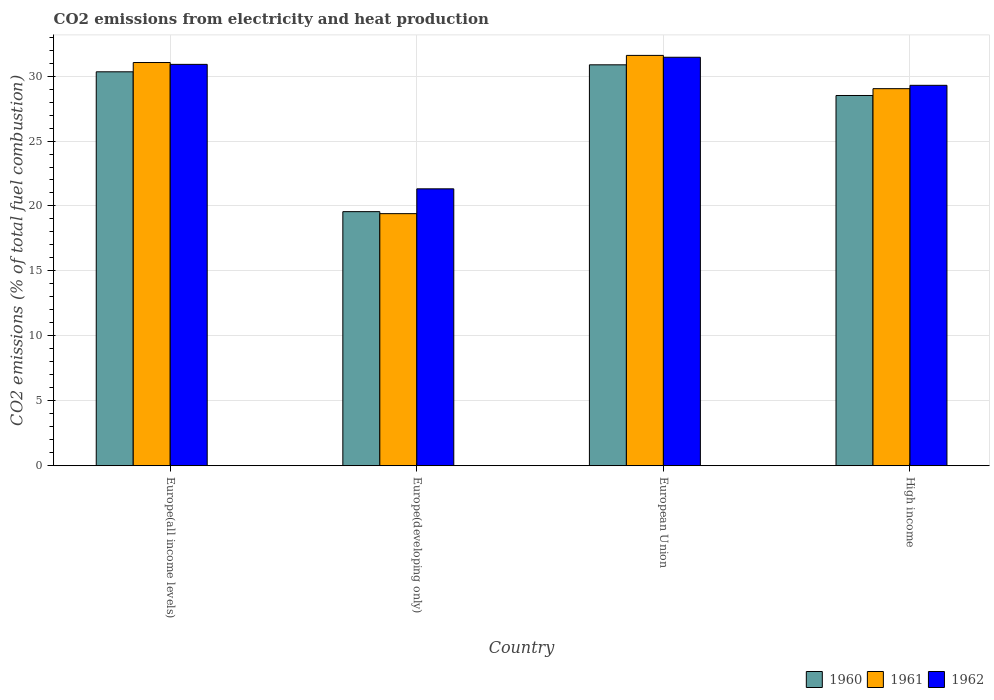How many groups of bars are there?
Your response must be concise. 4. Are the number of bars on each tick of the X-axis equal?
Your answer should be compact. Yes. How many bars are there on the 3rd tick from the right?
Your answer should be compact. 3. What is the label of the 4th group of bars from the left?
Your answer should be compact. High income. In how many cases, is the number of bars for a given country not equal to the number of legend labels?
Offer a terse response. 0. What is the amount of CO2 emitted in 1960 in High income?
Ensure brevity in your answer.  28.51. Across all countries, what is the maximum amount of CO2 emitted in 1960?
Your answer should be very brief. 30.87. Across all countries, what is the minimum amount of CO2 emitted in 1961?
Offer a very short reply. 19.41. In which country was the amount of CO2 emitted in 1962 minimum?
Provide a short and direct response. Europe(developing only). What is the total amount of CO2 emitted in 1960 in the graph?
Keep it short and to the point. 109.27. What is the difference between the amount of CO2 emitted in 1960 in Europe(developing only) and that in High income?
Offer a terse response. -8.94. What is the difference between the amount of CO2 emitted in 1960 in High income and the amount of CO2 emitted in 1961 in European Union?
Provide a succinct answer. -3.09. What is the average amount of CO2 emitted in 1962 per country?
Make the answer very short. 28.24. What is the difference between the amount of CO2 emitted of/in 1961 and amount of CO2 emitted of/in 1962 in European Union?
Keep it short and to the point. 0.14. In how many countries, is the amount of CO2 emitted in 1961 greater than 27 %?
Offer a very short reply. 3. What is the ratio of the amount of CO2 emitted in 1960 in Europe(all income levels) to that in Europe(developing only)?
Ensure brevity in your answer.  1.55. What is the difference between the highest and the second highest amount of CO2 emitted in 1962?
Your answer should be very brief. -1.61. What is the difference between the highest and the lowest amount of CO2 emitted in 1960?
Ensure brevity in your answer.  11.31. What does the 2nd bar from the left in Europe(all income levels) represents?
Give a very brief answer. 1961. What does the 3rd bar from the right in High income represents?
Give a very brief answer. 1960. How many countries are there in the graph?
Provide a short and direct response. 4. Are the values on the major ticks of Y-axis written in scientific E-notation?
Offer a terse response. No. Does the graph contain any zero values?
Your answer should be very brief. No. Where does the legend appear in the graph?
Provide a succinct answer. Bottom right. What is the title of the graph?
Provide a succinct answer. CO2 emissions from electricity and heat production. What is the label or title of the X-axis?
Keep it short and to the point. Country. What is the label or title of the Y-axis?
Your response must be concise. CO2 emissions (% of total fuel combustion). What is the CO2 emissions (% of total fuel combustion) of 1960 in Europe(all income levels)?
Give a very brief answer. 30.33. What is the CO2 emissions (% of total fuel combustion) of 1961 in Europe(all income levels)?
Provide a succinct answer. 31.04. What is the CO2 emissions (% of total fuel combustion) in 1962 in Europe(all income levels)?
Make the answer very short. 30.9. What is the CO2 emissions (% of total fuel combustion) in 1960 in Europe(developing only)?
Make the answer very short. 19.56. What is the CO2 emissions (% of total fuel combustion) of 1961 in Europe(developing only)?
Offer a terse response. 19.41. What is the CO2 emissions (% of total fuel combustion) in 1962 in Europe(developing only)?
Offer a very short reply. 21.32. What is the CO2 emissions (% of total fuel combustion) in 1960 in European Union?
Provide a short and direct response. 30.87. What is the CO2 emissions (% of total fuel combustion) in 1961 in European Union?
Keep it short and to the point. 31.59. What is the CO2 emissions (% of total fuel combustion) in 1962 in European Union?
Keep it short and to the point. 31.45. What is the CO2 emissions (% of total fuel combustion) in 1960 in High income?
Offer a very short reply. 28.51. What is the CO2 emissions (% of total fuel combustion) of 1961 in High income?
Your response must be concise. 29.03. What is the CO2 emissions (% of total fuel combustion) in 1962 in High income?
Offer a very short reply. 29.29. Across all countries, what is the maximum CO2 emissions (% of total fuel combustion) in 1960?
Offer a terse response. 30.87. Across all countries, what is the maximum CO2 emissions (% of total fuel combustion) in 1961?
Ensure brevity in your answer.  31.59. Across all countries, what is the maximum CO2 emissions (% of total fuel combustion) of 1962?
Keep it short and to the point. 31.45. Across all countries, what is the minimum CO2 emissions (% of total fuel combustion) in 1960?
Offer a terse response. 19.56. Across all countries, what is the minimum CO2 emissions (% of total fuel combustion) of 1961?
Your response must be concise. 19.41. Across all countries, what is the minimum CO2 emissions (% of total fuel combustion) in 1962?
Ensure brevity in your answer.  21.32. What is the total CO2 emissions (% of total fuel combustion) of 1960 in the graph?
Offer a very short reply. 109.27. What is the total CO2 emissions (% of total fuel combustion) of 1961 in the graph?
Offer a very short reply. 111.08. What is the total CO2 emissions (% of total fuel combustion) in 1962 in the graph?
Your answer should be very brief. 112.96. What is the difference between the CO2 emissions (% of total fuel combustion) in 1960 in Europe(all income levels) and that in Europe(developing only)?
Offer a terse response. 10.77. What is the difference between the CO2 emissions (% of total fuel combustion) of 1961 in Europe(all income levels) and that in Europe(developing only)?
Give a very brief answer. 11.64. What is the difference between the CO2 emissions (% of total fuel combustion) of 1962 in Europe(all income levels) and that in Europe(developing only)?
Offer a very short reply. 9.58. What is the difference between the CO2 emissions (% of total fuel combustion) of 1960 in Europe(all income levels) and that in European Union?
Keep it short and to the point. -0.54. What is the difference between the CO2 emissions (% of total fuel combustion) in 1961 in Europe(all income levels) and that in European Union?
Offer a terse response. -0.55. What is the difference between the CO2 emissions (% of total fuel combustion) of 1962 in Europe(all income levels) and that in European Union?
Your response must be concise. -0.55. What is the difference between the CO2 emissions (% of total fuel combustion) of 1960 in Europe(all income levels) and that in High income?
Offer a terse response. 1.82. What is the difference between the CO2 emissions (% of total fuel combustion) in 1961 in Europe(all income levels) and that in High income?
Ensure brevity in your answer.  2.01. What is the difference between the CO2 emissions (% of total fuel combustion) of 1962 in Europe(all income levels) and that in High income?
Ensure brevity in your answer.  1.61. What is the difference between the CO2 emissions (% of total fuel combustion) in 1960 in Europe(developing only) and that in European Union?
Ensure brevity in your answer.  -11.31. What is the difference between the CO2 emissions (% of total fuel combustion) in 1961 in Europe(developing only) and that in European Union?
Your response must be concise. -12.19. What is the difference between the CO2 emissions (% of total fuel combustion) in 1962 in Europe(developing only) and that in European Union?
Provide a short and direct response. -10.13. What is the difference between the CO2 emissions (% of total fuel combustion) of 1960 in Europe(developing only) and that in High income?
Provide a short and direct response. -8.94. What is the difference between the CO2 emissions (% of total fuel combustion) of 1961 in Europe(developing only) and that in High income?
Make the answer very short. -9.62. What is the difference between the CO2 emissions (% of total fuel combustion) in 1962 in Europe(developing only) and that in High income?
Your answer should be very brief. -7.97. What is the difference between the CO2 emissions (% of total fuel combustion) in 1960 in European Union and that in High income?
Provide a succinct answer. 2.36. What is the difference between the CO2 emissions (% of total fuel combustion) in 1961 in European Union and that in High income?
Your answer should be very brief. 2.56. What is the difference between the CO2 emissions (% of total fuel combustion) of 1962 in European Union and that in High income?
Give a very brief answer. 2.16. What is the difference between the CO2 emissions (% of total fuel combustion) of 1960 in Europe(all income levels) and the CO2 emissions (% of total fuel combustion) of 1961 in Europe(developing only)?
Make the answer very short. 10.92. What is the difference between the CO2 emissions (% of total fuel combustion) of 1960 in Europe(all income levels) and the CO2 emissions (% of total fuel combustion) of 1962 in Europe(developing only)?
Offer a terse response. 9.01. What is the difference between the CO2 emissions (% of total fuel combustion) in 1961 in Europe(all income levels) and the CO2 emissions (% of total fuel combustion) in 1962 in Europe(developing only)?
Your answer should be compact. 9.73. What is the difference between the CO2 emissions (% of total fuel combustion) of 1960 in Europe(all income levels) and the CO2 emissions (% of total fuel combustion) of 1961 in European Union?
Provide a short and direct response. -1.26. What is the difference between the CO2 emissions (% of total fuel combustion) of 1960 in Europe(all income levels) and the CO2 emissions (% of total fuel combustion) of 1962 in European Union?
Your response must be concise. -1.12. What is the difference between the CO2 emissions (% of total fuel combustion) of 1961 in Europe(all income levels) and the CO2 emissions (% of total fuel combustion) of 1962 in European Union?
Ensure brevity in your answer.  -0.41. What is the difference between the CO2 emissions (% of total fuel combustion) in 1960 in Europe(all income levels) and the CO2 emissions (% of total fuel combustion) in 1961 in High income?
Keep it short and to the point. 1.3. What is the difference between the CO2 emissions (% of total fuel combustion) in 1960 in Europe(all income levels) and the CO2 emissions (% of total fuel combustion) in 1962 in High income?
Your answer should be very brief. 1.04. What is the difference between the CO2 emissions (% of total fuel combustion) of 1961 in Europe(all income levels) and the CO2 emissions (% of total fuel combustion) of 1962 in High income?
Your answer should be very brief. 1.75. What is the difference between the CO2 emissions (% of total fuel combustion) of 1960 in Europe(developing only) and the CO2 emissions (% of total fuel combustion) of 1961 in European Union?
Your answer should be very brief. -12.03. What is the difference between the CO2 emissions (% of total fuel combustion) in 1960 in Europe(developing only) and the CO2 emissions (% of total fuel combustion) in 1962 in European Union?
Make the answer very short. -11.89. What is the difference between the CO2 emissions (% of total fuel combustion) of 1961 in Europe(developing only) and the CO2 emissions (% of total fuel combustion) of 1962 in European Union?
Your answer should be compact. -12.04. What is the difference between the CO2 emissions (% of total fuel combustion) in 1960 in Europe(developing only) and the CO2 emissions (% of total fuel combustion) in 1961 in High income?
Provide a short and direct response. -9.47. What is the difference between the CO2 emissions (% of total fuel combustion) in 1960 in Europe(developing only) and the CO2 emissions (% of total fuel combustion) in 1962 in High income?
Offer a very short reply. -9.73. What is the difference between the CO2 emissions (% of total fuel combustion) in 1961 in Europe(developing only) and the CO2 emissions (% of total fuel combustion) in 1962 in High income?
Your response must be concise. -9.88. What is the difference between the CO2 emissions (% of total fuel combustion) of 1960 in European Union and the CO2 emissions (% of total fuel combustion) of 1961 in High income?
Offer a very short reply. 1.84. What is the difference between the CO2 emissions (% of total fuel combustion) of 1960 in European Union and the CO2 emissions (% of total fuel combustion) of 1962 in High income?
Your response must be concise. 1.58. What is the difference between the CO2 emissions (% of total fuel combustion) of 1961 in European Union and the CO2 emissions (% of total fuel combustion) of 1962 in High income?
Provide a succinct answer. 2.3. What is the average CO2 emissions (% of total fuel combustion) in 1960 per country?
Give a very brief answer. 27.32. What is the average CO2 emissions (% of total fuel combustion) in 1961 per country?
Offer a very short reply. 27.77. What is the average CO2 emissions (% of total fuel combustion) of 1962 per country?
Offer a terse response. 28.24. What is the difference between the CO2 emissions (% of total fuel combustion) in 1960 and CO2 emissions (% of total fuel combustion) in 1961 in Europe(all income levels)?
Offer a very short reply. -0.71. What is the difference between the CO2 emissions (% of total fuel combustion) of 1960 and CO2 emissions (% of total fuel combustion) of 1962 in Europe(all income levels)?
Your answer should be very brief. -0.57. What is the difference between the CO2 emissions (% of total fuel combustion) of 1961 and CO2 emissions (% of total fuel combustion) of 1962 in Europe(all income levels)?
Give a very brief answer. 0.14. What is the difference between the CO2 emissions (% of total fuel combustion) in 1960 and CO2 emissions (% of total fuel combustion) in 1961 in Europe(developing only)?
Offer a very short reply. 0.15. What is the difference between the CO2 emissions (% of total fuel combustion) of 1960 and CO2 emissions (% of total fuel combustion) of 1962 in Europe(developing only)?
Offer a terse response. -1.76. What is the difference between the CO2 emissions (% of total fuel combustion) of 1961 and CO2 emissions (% of total fuel combustion) of 1962 in Europe(developing only)?
Make the answer very short. -1.91. What is the difference between the CO2 emissions (% of total fuel combustion) in 1960 and CO2 emissions (% of total fuel combustion) in 1961 in European Union?
Your answer should be very brief. -0.73. What is the difference between the CO2 emissions (% of total fuel combustion) of 1960 and CO2 emissions (% of total fuel combustion) of 1962 in European Union?
Keep it short and to the point. -0.58. What is the difference between the CO2 emissions (% of total fuel combustion) of 1961 and CO2 emissions (% of total fuel combustion) of 1962 in European Union?
Your response must be concise. 0.14. What is the difference between the CO2 emissions (% of total fuel combustion) in 1960 and CO2 emissions (% of total fuel combustion) in 1961 in High income?
Your response must be concise. -0.53. What is the difference between the CO2 emissions (% of total fuel combustion) of 1960 and CO2 emissions (% of total fuel combustion) of 1962 in High income?
Your answer should be compact. -0.78. What is the difference between the CO2 emissions (% of total fuel combustion) in 1961 and CO2 emissions (% of total fuel combustion) in 1962 in High income?
Your answer should be compact. -0.26. What is the ratio of the CO2 emissions (% of total fuel combustion) of 1960 in Europe(all income levels) to that in Europe(developing only)?
Make the answer very short. 1.55. What is the ratio of the CO2 emissions (% of total fuel combustion) of 1961 in Europe(all income levels) to that in Europe(developing only)?
Your answer should be very brief. 1.6. What is the ratio of the CO2 emissions (% of total fuel combustion) of 1962 in Europe(all income levels) to that in Europe(developing only)?
Your answer should be compact. 1.45. What is the ratio of the CO2 emissions (% of total fuel combustion) in 1960 in Europe(all income levels) to that in European Union?
Give a very brief answer. 0.98. What is the ratio of the CO2 emissions (% of total fuel combustion) of 1961 in Europe(all income levels) to that in European Union?
Provide a succinct answer. 0.98. What is the ratio of the CO2 emissions (% of total fuel combustion) in 1962 in Europe(all income levels) to that in European Union?
Provide a succinct answer. 0.98. What is the ratio of the CO2 emissions (% of total fuel combustion) in 1960 in Europe(all income levels) to that in High income?
Offer a very short reply. 1.06. What is the ratio of the CO2 emissions (% of total fuel combustion) of 1961 in Europe(all income levels) to that in High income?
Offer a very short reply. 1.07. What is the ratio of the CO2 emissions (% of total fuel combustion) in 1962 in Europe(all income levels) to that in High income?
Offer a terse response. 1.06. What is the ratio of the CO2 emissions (% of total fuel combustion) in 1960 in Europe(developing only) to that in European Union?
Ensure brevity in your answer.  0.63. What is the ratio of the CO2 emissions (% of total fuel combustion) in 1961 in Europe(developing only) to that in European Union?
Your answer should be compact. 0.61. What is the ratio of the CO2 emissions (% of total fuel combustion) of 1962 in Europe(developing only) to that in European Union?
Offer a terse response. 0.68. What is the ratio of the CO2 emissions (% of total fuel combustion) in 1960 in Europe(developing only) to that in High income?
Offer a very short reply. 0.69. What is the ratio of the CO2 emissions (% of total fuel combustion) in 1961 in Europe(developing only) to that in High income?
Provide a short and direct response. 0.67. What is the ratio of the CO2 emissions (% of total fuel combustion) of 1962 in Europe(developing only) to that in High income?
Keep it short and to the point. 0.73. What is the ratio of the CO2 emissions (% of total fuel combustion) of 1960 in European Union to that in High income?
Keep it short and to the point. 1.08. What is the ratio of the CO2 emissions (% of total fuel combustion) in 1961 in European Union to that in High income?
Make the answer very short. 1.09. What is the ratio of the CO2 emissions (% of total fuel combustion) of 1962 in European Union to that in High income?
Your answer should be very brief. 1.07. What is the difference between the highest and the second highest CO2 emissions (% of total fuel combustion) in 1960?
Your answer should be very brief. 0.54. What is the difference between the highest and the second highest CO2 emissions (% of total fuel combustion) of 1961?
Your answer should be compact. 0.55. What is the difference between the highest and the second highest CO2 emissions (% of total fuel combustion) of 1962?
Ensure brevity in your answer.  0.55. What is the difference between the highest and the lowest CO2 emissions (% of total fuel combustion) of 1960?
Offer a terse response. 11.31. What is the difference between the highest and the lowest CO2 emissions (% of total fuel combustion) in 1961?
Provide a succinct answer. 12.19. What is the difference between the highest and the lowest CO2 emissions (% of total fuel combustion) in 1962?
Keep it short and to the point. 10.13. 